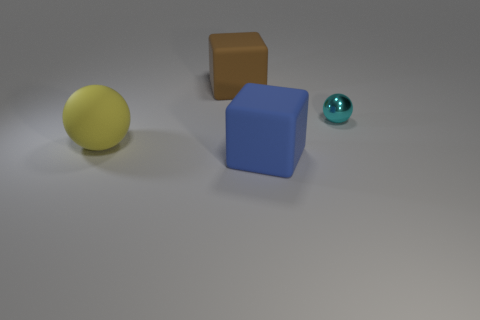Are there any other things that are the same material as the small ball?
Ensure brevity in your answer.  No. How many things are rubber things that are in front of the yellow object or large rubber things to the left of the blue block?
Make the answer very short. 3. How many other objects are there of the same size as the blue rubber object?
Offer a terse response. 2. What is the size of the matte object that is both in front of the metal object and right of the large rubber ball?
Your response must be concise. Large. How many big objects are green cylinders or matte balls?
Keep it short and to the point. 1. The big thing that is behind the big yellow rubber thing has what shape?
Provide a succinct answer. Cube. What number of green matte blocks are there?
Keep it short and to the point. 0. Does the small ball have the same material as the yellow thing?
Give a very brief answer. No. Is the number of big rubber objects to the right of the big yellow ball greater than the number of big purple rubber things?
Offer a terse response. Yes. What number of things are big blue rubber spheres or large matte things left of the blue matte thing?
Make the answer very short. 2. 